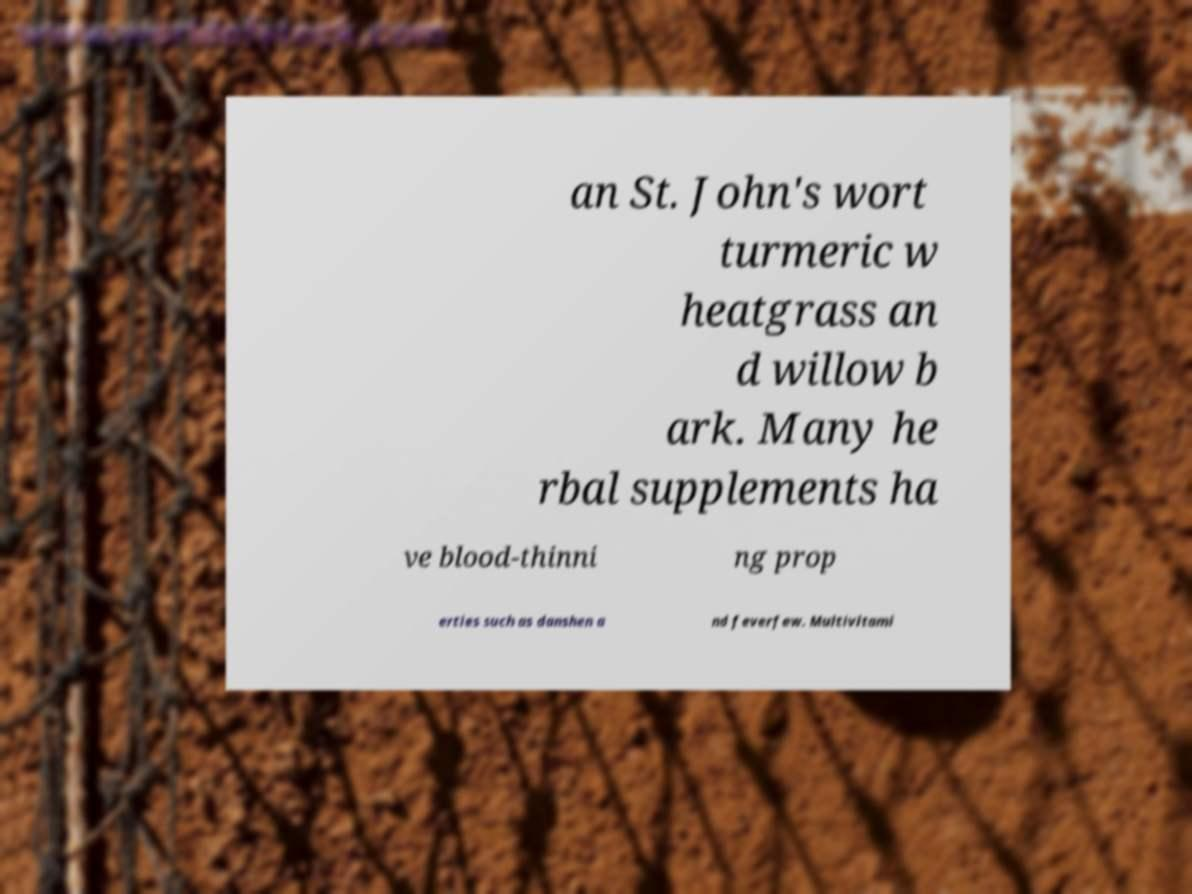Please identify and transcribe the text found in this image. an St. John's wort turmeric w heatgrass an d willow b ark. Many he rbal supplements ha ve blood-thinni ng prop erties such as danshen a nd feverfew. Multivitami 